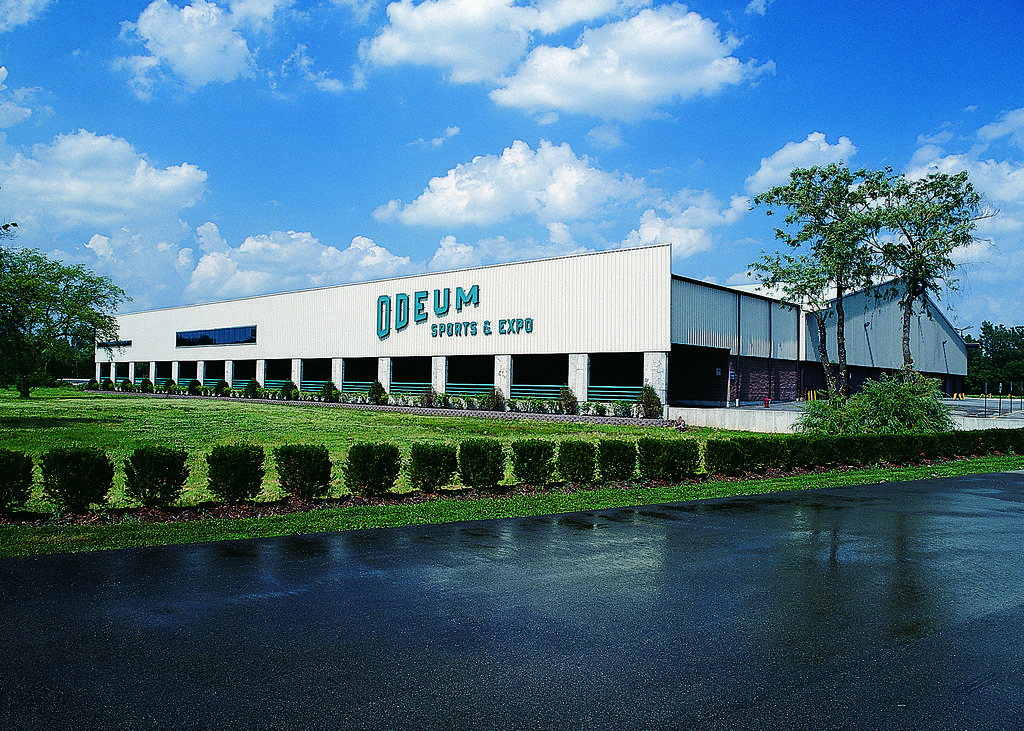Please provide a concise description of this image. This image is taken outdoors. At the bottom of the image there is a pond with water. At the top of the image there is a sky with clouds. In the middle of the image there is a ground with grass, a few plants and trees on it and there is a room with walls, pillars, doors and a roof and there is a text on the wall. 